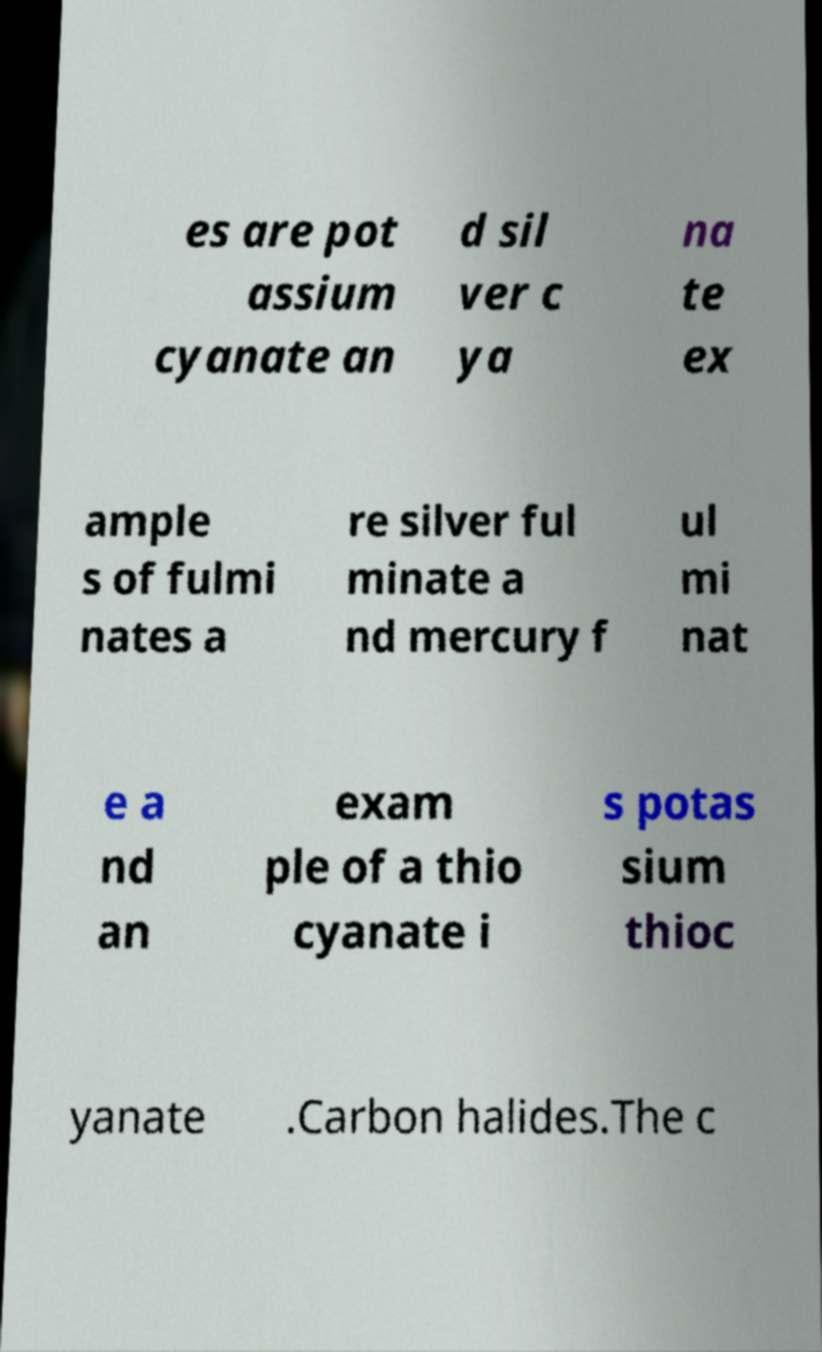Could you extract and type out the text from this image? es are pot assium cyanate an d sil ver c ya na te ex ample s of fulmi nates a re silver ful minate a nd mercury f ul mi nat e a nd an exam ple of a thio cyanate i s potas sium thioc yanate .Carbon halides.The c 